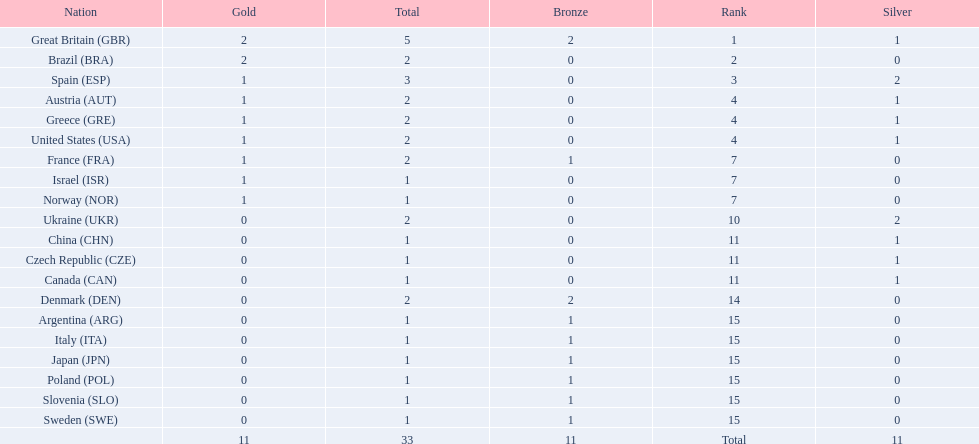How many medals did each country receive? 5, 2, 3, 2, 2, 2, 2, 1, 1, 2, 1, 1, 1, 2, 1, 1, 1, 1, 1, 1. Which country received 3 medals? Spain (ESP). 